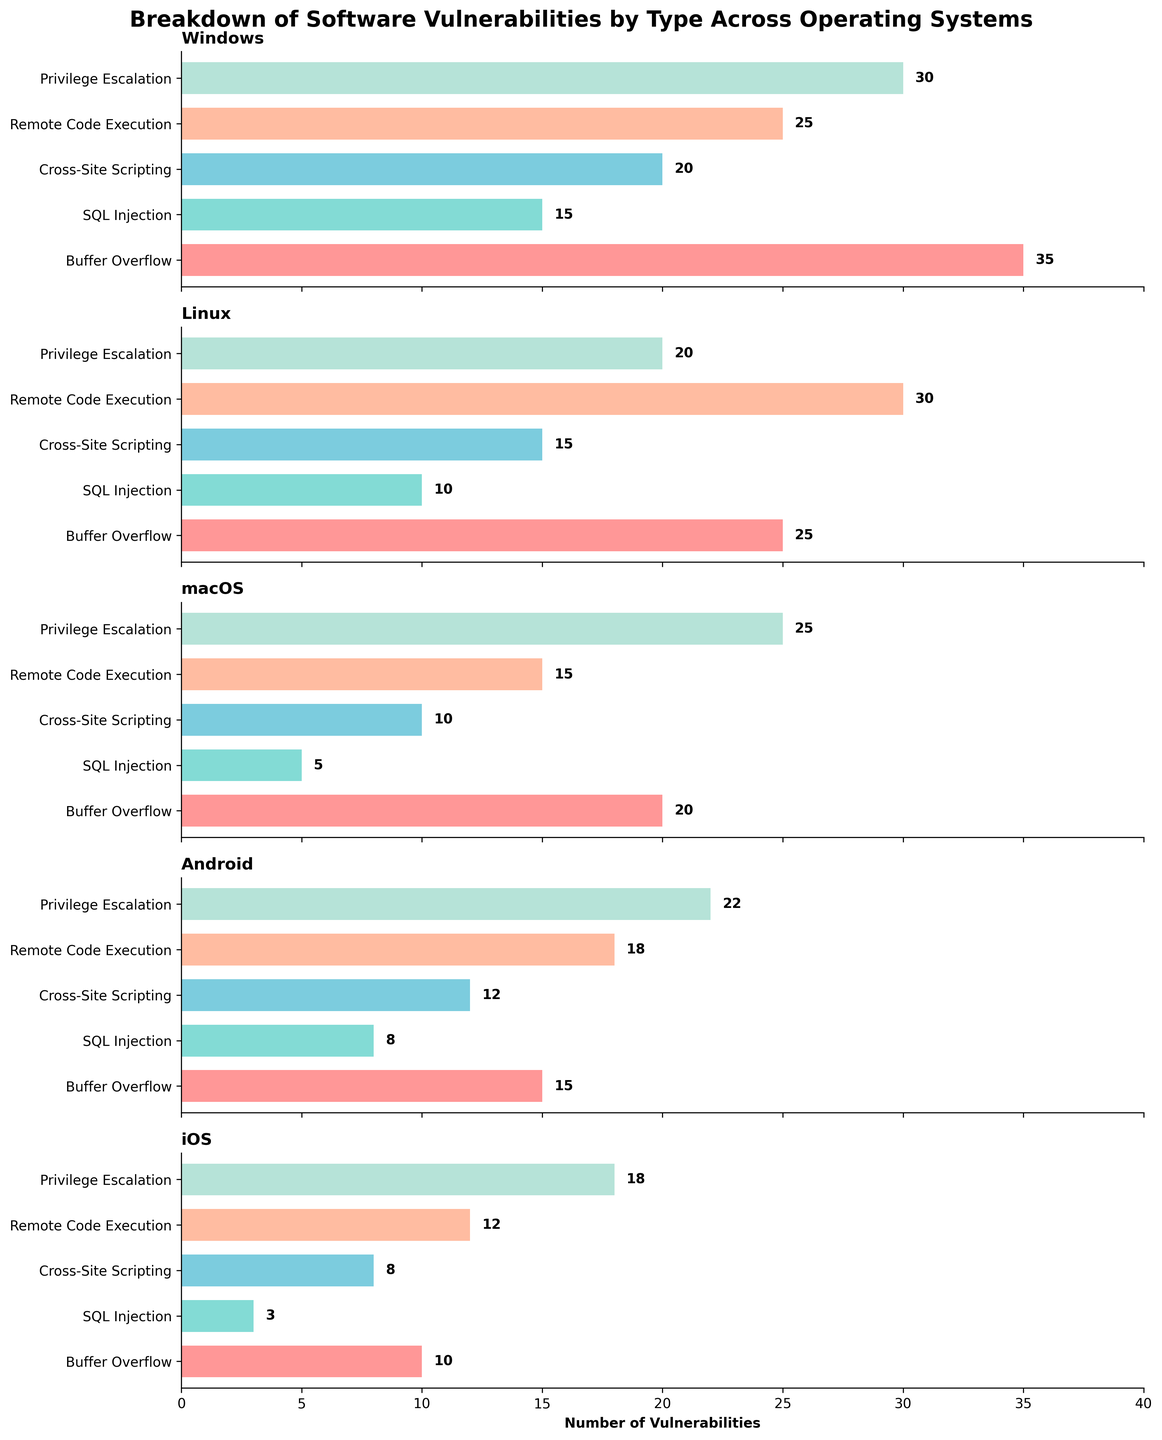What is the operating system with the highest number of Buffer Overflow vulnerabilities? The chart for Windows shows a bar representing Buffer Overflow vulnerabilities reaching a value of 35, which appears to be the highest among all the OSes displayed. By closely examining the lengths of these bars across subplots, it becomes evident that the bar corresponding to Windows for Buffer Overflow stands out the most.
Answer: Windows Which operating system has the lowest number of SQL Injection vulnerabilities? The chart for iOS indicates the smallest bar for SQL Injection vulnerabilities, which is labeled with a value of 3. By looking at the SQL Injection bars across each OS, it's clear that iOS has the fewest vulnerabilities in this category.
Answer: iOS Compare the number of Remote Code Execution vulnerabilities between Linux and macOS. Which OS has more? The Linux subplot displays a bar for Remote Code Execution with a length corresponding to 30, whereas the macOS subplot shows a similar bar equating to 15. Thus, Linux has more Remote Code Execution vulnerabilities.
Answer: Linux Which type of vulnerability has the highest total count across all operating systems? Summing up the values for each vulnerability type across all subplots:
Buffer Overflow: 35 + 25 + 20 + 15 + 10 = 105
SQL Injection: 15 + 10 + 5 + 8 + 3 = 41
Cross-Site Scripting: 20 + 15 + 10 + 12 + 8 = 65
Remote Code Execution: 25 + 30 + 15 + 18 + 12 = 100
Privilege Escalation: 30 + 20 + 25 + 22 + 18 = 115
It is clear that Privilege Escalation with a total of 115 is the highest.
Answer: Privilege Escalation Which category of vulnerabilities does Android have the highest count in? Observing the bars for Android, the Remote Code Execution bar extends to an 18, which is the highest among the different vulnerability types for this OS.
Answer: Remote Code Execution Between Windows and iOS, find the total number of Cross-Site Scripting vulnerabilities. From the subplots, Windows has 20 and iOS has 8 Cross-Site Scripting vulnerabilities:
20 (Windows) + 8 (iOS) = 28.
Answer: 28 Which operating system has a consistent pattern of relatively low vulnerabilities across all categories? By examining the bars across the subplots, iOS shows consistently shorter bars in each category compared to other operating systems, indicating relatively lower numbers.
Answer: iOS What is the total number of SQL Injection vulnerabilities identified across all operating systems? Adding the SQL Injection values for all OSes:
15 (Windows) + 10 (Linux) + 5 (macOS) + 8 (Android) + 3 (iOS) = 41.
Answer: 41 For macOS, compare the count of Privilege Escalation to Buffer Overflow vulnerabilities. Which is higher? The macOS subplot shows that the bar for Privilege Escalation reaches 25, whereas the bar for Buffer Overflow reaches 20, indicating that Privilege Escalation has a higher count.
Answer: Privilege Escalation 